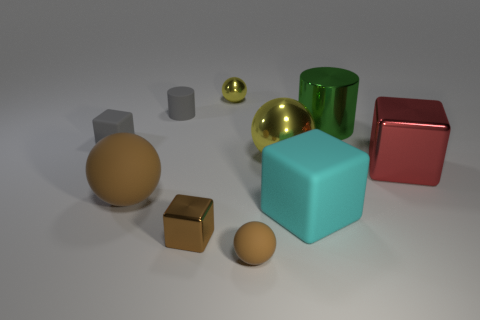There is a red shiny thing on the right side of the small cylinder; what number of big spheres are in front of it?
Make the answer very short. 1. There is a cylinder that is the same size as the red metal cube; what is its material?
Offer a very short reply. Metal. There is a yellow shiny object behind the big yellow shiny sphere; does it have the same shape as the big red metal object?
Offer a terse response. No. Are there more tiny brown objects behind the cyan matte thing than big yellow objects in front of the brown metal block?
Your response must be concise. No. What number of other large things are made of the same material as the large brown object?
Your answer should be very brief. 1. Do the brown metal cube and the green metallic cylinder have the same size?
Offer a very short reply. No. What is the color of the metal cylinder?
Give a very brief answer. Green. What number of objects are either large gray cylinders or tiny metal objects?
Make the answer very short. 2. Are there any big gray things that have the same shape as the large red thing?
Ensure brevity in your answer.  No. Does the tiny matte thing in front of the large shiny sphere have the same color as the tiny shiny sphere?
Offer a very short reply. No. 